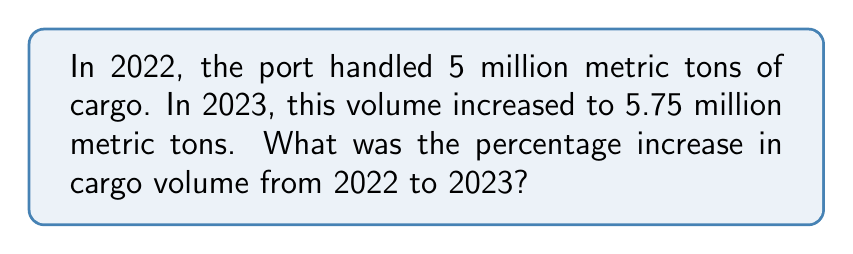Can you answer this question? To calculate the percentage increase, we'll follow these steps:

1. Calculate the absolute increase:
   $\text{Increase} = \text{New Value} - \text{Original Value}$
   $\text{Increase} = 5.75 - 5 = 0.75$ million metric tons

2. Calculate the percentage increase:
   $\text{Percentage Increase} = \frac{\text{Increase}}{\text{Original Value}} \times 100\%$
   
   $\text{Percentage Increase} = \frac{0.75}{5} \times 100\%$

3. Simplify the fraction:
   $\frac{0.75}{5} = \frac{3}{20} = 0.15$

4. Convert to percentage:
   $0.15 \times 100\% = 15\%$

Therefore, the percentage increase in cargo volume from 2022 to 2023 was 15%.
Answer: 15% 